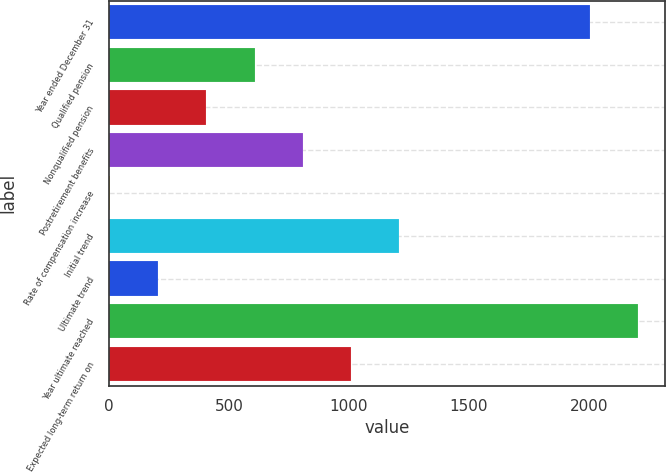Convert chart to OTSL. <chart><loc_0><loc_0><loc_500><loc_500><bar_chart><fcel>Year ended December 31<fcel>Qualified pension<fcel>Nonqualified pension<fcel>Postretirement benefits<fcel>Rate of compensation increase<fcel>Initial trend<fcel>Ultimate trend<fcel>Year ultimate reached<fcel>Expected long-term return on<nl><fcel>2006<fcel>606.1<fcel>405.4<fcel>806.8<fcel>4<fcel>1208.2<fcel>204.7<fcel>2206.7<fcel>1007.5<nl></chart> 